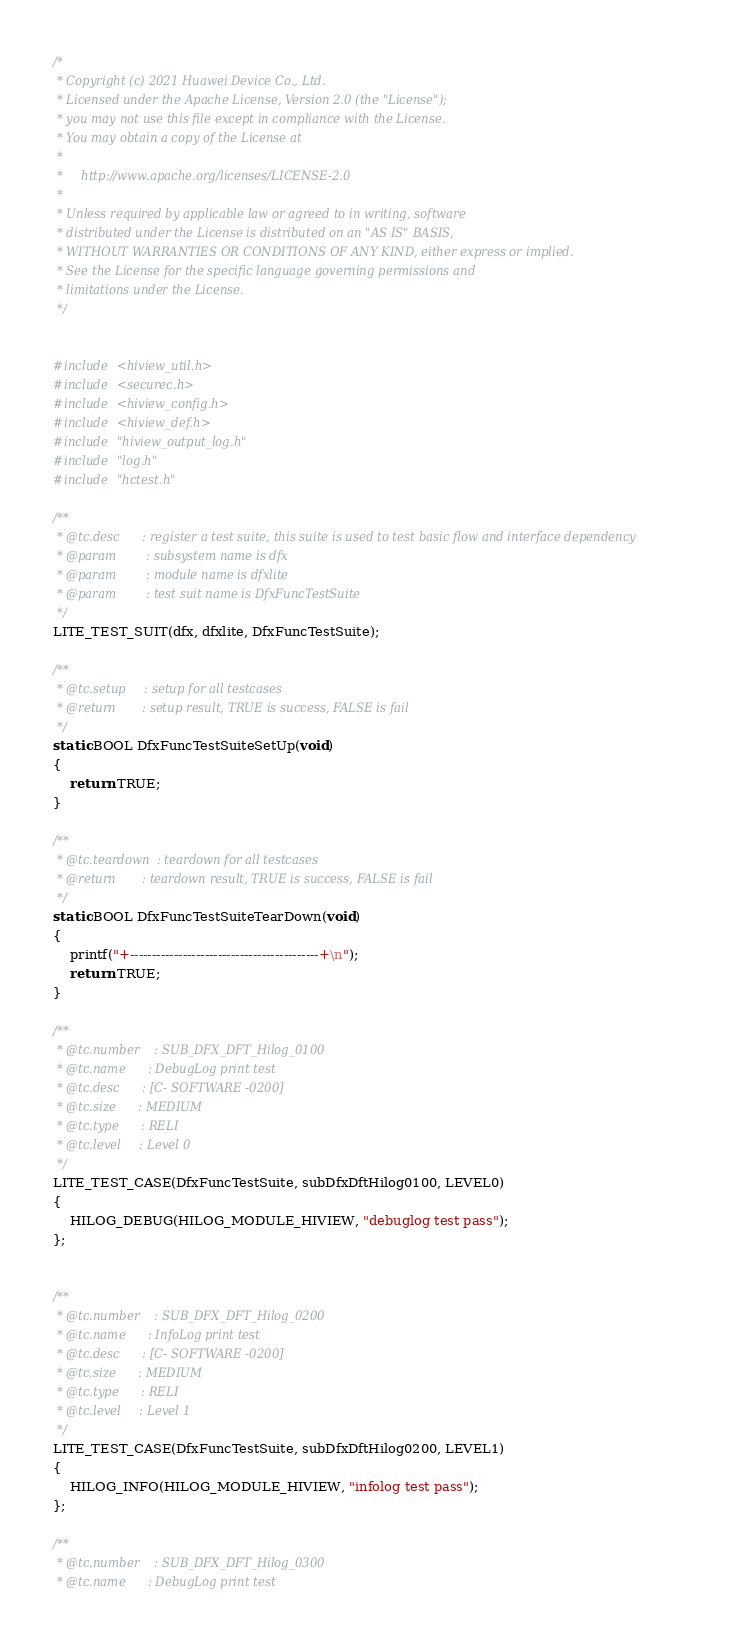<code> <loc_0><loc_0><loc_500><loc_500><_C_>/*
 * Copyright (c) 2021 Huawei Device Co., Ltd.
 * Licensed under the Apache License, Version 2.0 (the "License");
 * you may not use this file except in compliance with the License.
 * You may obtain a copy of the License at
 *
 *     http://www.apache.org/licenses/LICENSE-2.0
 *
 * Unless required by applicable law or agreed to in writing, software
 * distributed under the License is distributed on an "AS IS" BASIS,
 * WITHOUT WARRANTIES OR CONDITIONS OF ANY KIND, either express or implied.
 * See the License for the specific language governing permissions and
 * limitations under the License.
 */


#include <hiview_util.h>
#include <securec.h>
#include <hiview_config.h>
#include <hiview_def.h>
#include "hiview_output_log.h"
#include "log.h"
#include "hctest.h"

/**
 * @tc.desc      : register a test suite, this suite is used to test basic flow and interface dependency
 * @param        : subsystem name is dfx
 * @param        : module name is dfxlite
 * @param        : test suit name is DfxFuncTestSuite
 */
LITE_TEST_SUIT(dfx, dfxlite, DfxFuncTestSuite);

/**
 * @tc.setup     : setup for all testcases
 * @return       : setup result, TRUE is success, FALSE is fail
 */
static BOOL DfxFuncTestSuiteSetUp(void)
{
    return TRUE;
}

/**
 * @tc.teardown  : teardown for all testcases
 * @return       : teardown result, TRUE is success, FALSE is fail
 */
static BOOL DfxFuncTestSuiteTearDown(void)
{
    printf("+-------------------------------------------+\n");
    return TRUE;
}

/**
 * @tc.number    : SUB_DFX_DFT_Hilog_0100
 * @tc.name      : DebugLog print test
 * @tc.desc      : [C- SOFTWARE -0200]
 * @tc.size      : MEDIUM
 * @tc.type      : RELI
 * @tc.level     : Level 0
 */
LITE_TEST_CASE(DfxFuncTestSuite, subDfxDftHilog0100, LEVEL0)
{
    HILOG_DEBUG(HILOG_MODULE_HIVIEW, "debuglog test pass");
};


/**
 * @tc.number    : SUB_DFX_DFT_Hilog_0200
 * @tc.name      : InfoLog print test
 * @tc.desc      : [C- SOFTWARE -0200]
 * @tc.size      : MEDIUM
 * @tc.type      : RELI
 * @tc.level     : Level 1
 */
LITE_TEST_CASE(DfxFuncTestSuite, subDfxDftHilog0200, LEVEL1)
{
    HILOG_INFO(HILOG_MODULE_HIVIEW, "infolog test pass");
};

/**
 * @tc.number    : SUB_DFX_DFT_Hilog_0300
 * @tc.name      : DebugLog print test</code> 